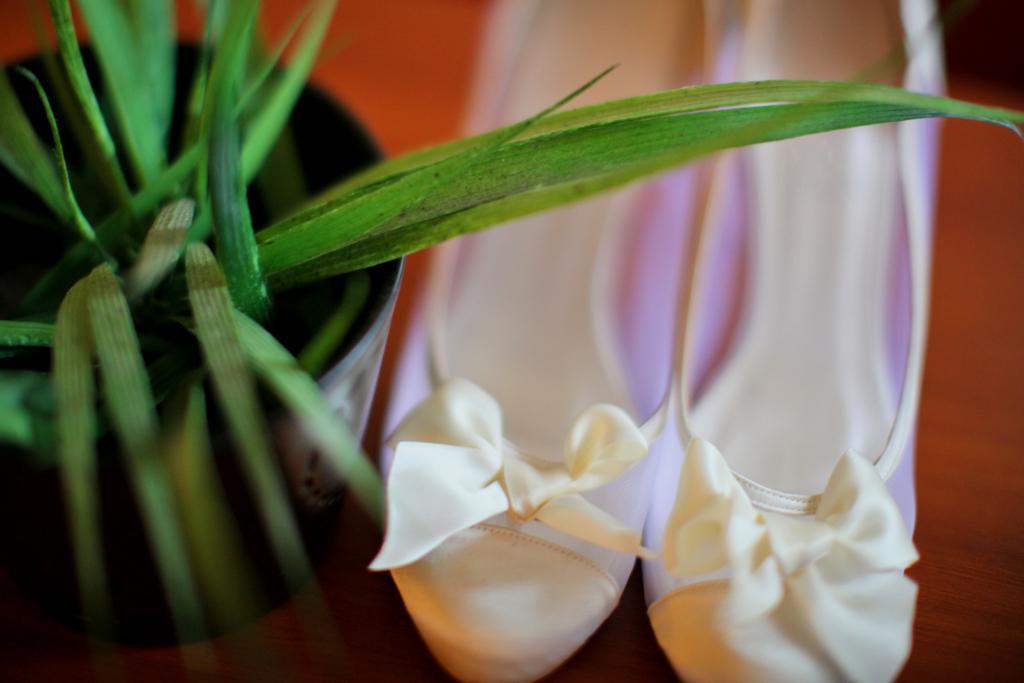Can you describe this image briefly? In the picture we can see a house plant and beside it we can see a pair of the foot wear. 